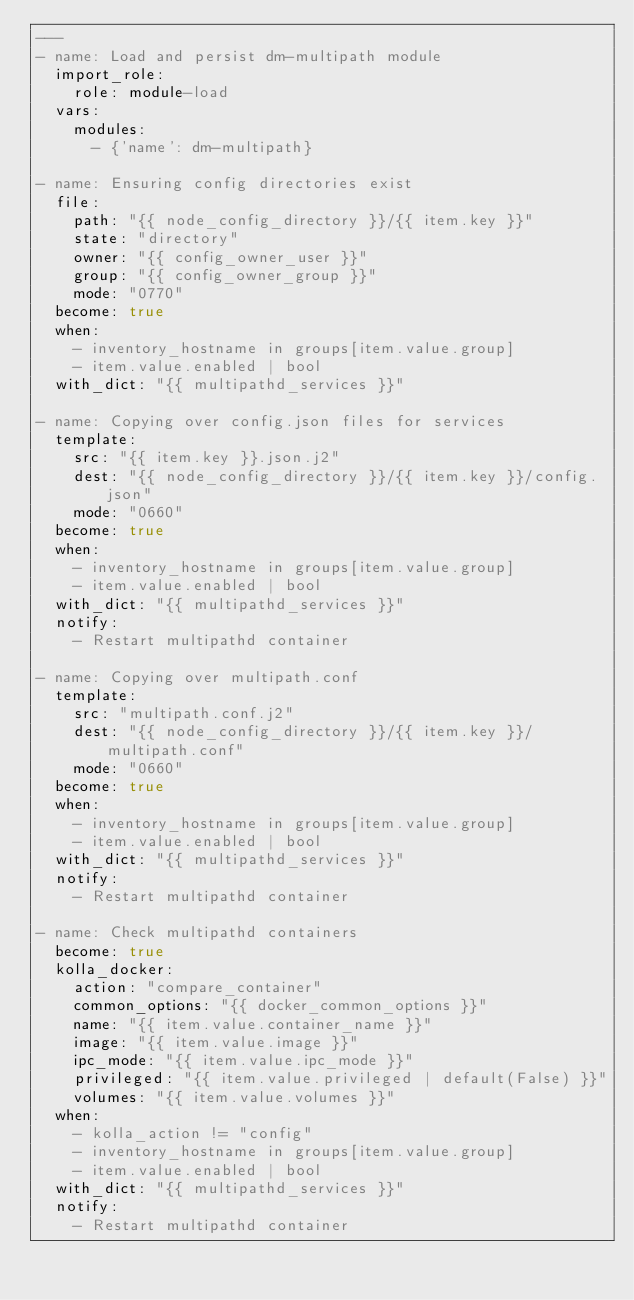Convert code to text. <code><loc_0><loc_0><loc_500><loc_500><_YAML_>---
- name: Load and persist dm-multipath module
  import_role:
    role: module-load
  vars:
    modules:
      - {'name': dm-multipath}

- name: Ensuring config directories exist
  file:
    path: "{{ node_config_directory }}/{{ item.key }}"
    state: "directory"
    owner: "{{ config_owner_user }}"
    group: "{{ config_owner_group }}"
    mode: "0770"
  become: true
  when:
    - inventory_hostname in groups[item.value.group]
    - item.value.enabled | bool
  with_dict: "{{ multipathd_services }}"

- name: Copying over config.json files for services
  template:
    src: "{{ item.key }}.json.j2"
    dest: "{{ node_config_directory }}/{{ item.key }}/config.json"
    mode: "0660"
  become: true
  when:
    - inventory_hostname in groups[item.value.group]
    - item.value.enabled | bool
  with_dict: "{{ multipathd_services }}"
  notify:
    - Restart multipathd container

- name: Copying over multipath.conf
  template:
    src: "multipath.conf.j2"
    dest: "{{ node_config_directory }}/{{ item.key }}/multipath.conf"
    mode: "0660"
  become: true
  when:
    - inventory_hostname in groups[item.value.group]
    - item.value.enabled | bool
  with_dict: "{{ multipathd_services }}"
  notify:
    - Restart multipathd container

- name: Check multipathd containers
  become: true
  kolla_docker:
    action: "compare_container"
    common_options: "{{ docker_common_options }}"
    name: "{{ item.value.container_name }}"
    image: "{{ item.value.image }}"
    ipc_mode: "{{ item.value.ipc_mode }}"
    privileged: "{{ item.value.privileged | default(False) }}"
    volumes: "{{ item.value.volumes }}"
  when:
    - kolla_action != "config"
    - inventory_hostname in groups[item.value.group]
    - item.value.enabled | bool
  with_dict: "{{ multipathd_services }}"
  notify:
    - Restart multipathd container
</code> 